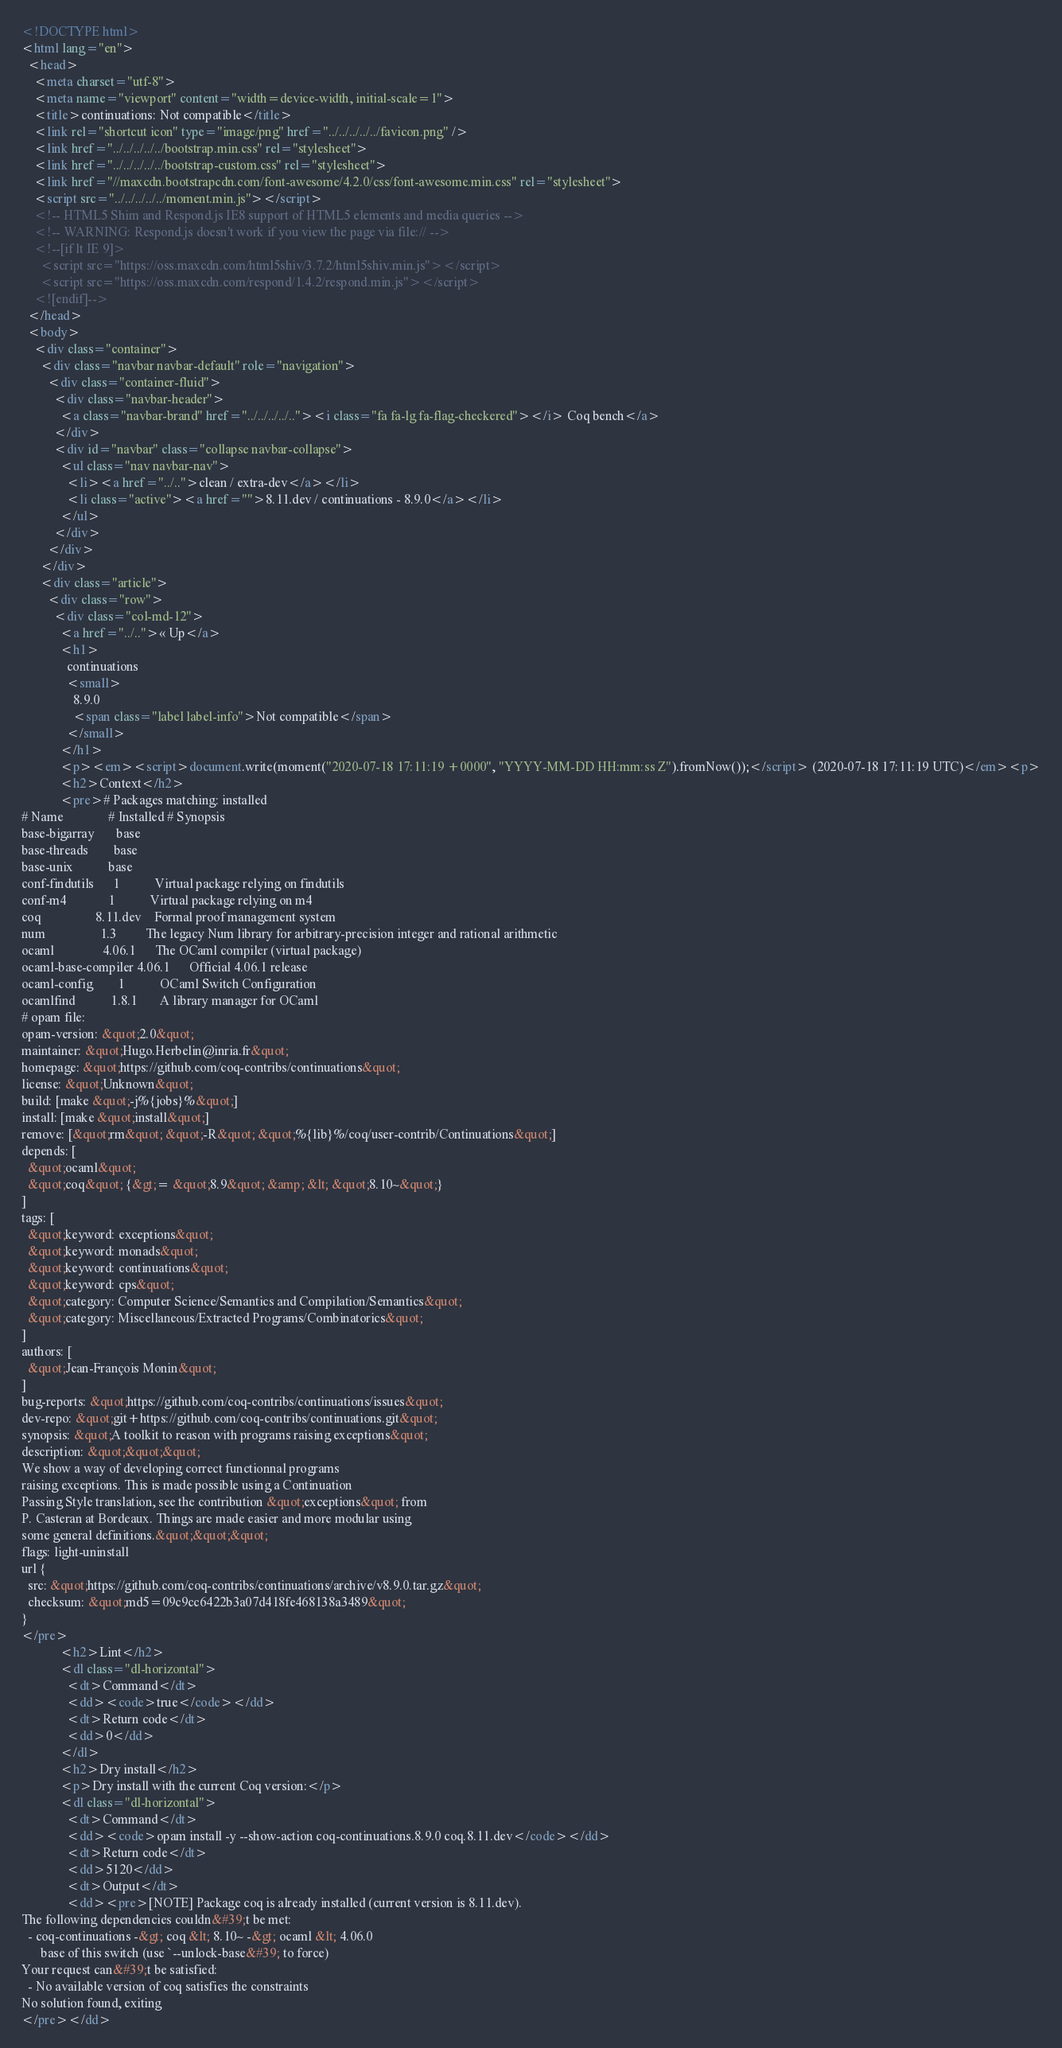Convert code to text. <code><loc_0><loc_0><loc_500><loc_500><_HTML_><!DOCTYPE html>
<html lang="en">
  <head>
    <meta charset="utf-8">
    <meta name="viewport" content="width=device-width, initial-scale=1">
    <title>continuations: Not compatible</title>
    <link rel="shortcut icon" type="image/png" href="../../../../../favicon.png" />
    <link href="../../../../../bootstrap.min.css" rel="stylesheet">
    <link href="../../../../../bootstrap-custom.css" rel="stylesheet">
    <link href="//maxcdn.bootstrapcdn.com/font-awesome/4.2.0/css/font-awesome.min.css" rel="stylesheet">
    <script src="../../../../../moment.min.js"></script>
    <!-- HTML5 Shim and Respond.js IE8 support of HTML5 elements and media queries -->
    <!-- WARNING: Respond.js doesn't work if you view the page via file:// -->
    <!--[if lt IE 9]>
      <script src="https://oss.maxcdn.com/html5shiv/3.7.2/html5shiv.min.js"></script>
      <script src="https://oss.maxcdn.com/respond/1.4.2/respond.min.js"></script>
    <![endif]-->
  </head>
  <body>
    <div class="container">
      <div class="navbar navbar-default" role="navigation">
        <div class="container-fluid">
          <div class="navbar-header">
            <a class="navbar-brand" href="../../../../.."><i class="fa fa-lg fa-flag-checkered"></i> Coq bench</a>
          </div>
          <div id="navbar" class="collapse navbar-collapse">
            <ul class="nav navbar-nav">
              <li><a href="../..">clean / extra-dev</a></li>
              <li class="active"><a href="">8.11.dev / continuations - 8.9.0</a></li>
            </ul>
          </div>
        </div>
      </div>
      <div class="article">
        <div class="row">
          <div class="col-md-12">
            <a href="../..">« Up</a>
            <h1>
              continuations
              <small>
                8.9.0
                <span class="label label-info">Not compatible</span>
              </small>
            </h1>
            <p><em><script>document.write(moment("2020-07-18 17:11:19 +0000", "YYYY-MM-DD HH:mm:ss Z").fromNow());</script> (2020-07-18 17:11:19 UTC)</em><p>
            <h2>Context</h2>
            <pre># Packages matching: installed
# Name              # Installed # Synopsis
base-bigarray       base
base-threads        base
base-unix           base
conf-findutils      1           Virtual package relying on findutils
conf-m4             1           Virtual package relying on m4
coq                 8.11.dev    Formal proof management system
num                 1.3         The legacy Num library for arbitrary-precision integer and rational arithmetic
ocaml               4.06.1      The OCaml compiler (virtual package)
ocaml-base-compiler 4.06.1      Official 4.06.1 release
ocaml-config        1           OCaml Switch Configuration
ocamlfind           1.8.1       A library manager for OCaml
# opam file:
opam-version: &quot;2.0&quot;
maintainer: &quot;Hugo.Herbelin@inria.fr&quot;
homepage: &quot;https://github.com/coq-contribs/continuations&quot;
license: &quot;Unknown&quot;
build: [make &quot;-j%{jobs}%&quot;]
install: [make &quot;install&quot;]
remove: [&quot;rm&quot; &quot;-R&quot; &quot;%{lib}%/coq/user-contrib/Continuations&quot;]
depends: [
  &quot;ocaml&quot;
  &quot;coq&quot; {&gt;= &quot;8.9&quot; &amp; &lt; &quot;8.10~&quot;}
]
tags: [
  &quot;keyword: exceptions&quot;
  &quot;keyword: monads&quot;
  &quot;keyword: continuations&quot;
  &quot;keyword: cps&quot;
  &quot;category: Computer Science/Semantics and Compilation/Semantics&quot;
  &quot;category: Miscellaneous/Extracted Programs/Combinatorics&quot;
]
authors: [
  &quot;Jean-François Monin&quot;
]
bug-reports: &quot;https://github.com/coq-contribs/continuations/issues&quot;
dev-repo: &quot;git+https://github.com/coq-contribs/continuations.git&quot;
synopsis: &quot;A toolkit to reason with programs raising exceptions&quot;
description: &quot;&quot;&quot;
We show a way of developing correct functionnal programs
raising exceptions. This is made possible using a Continuation
Passing Style translation, see the contribution &quot;exceptions&quot; from
P. Casteran at Bordeaux. Things are made easier and more modular using
some general definitions.&quot;&quot;&quot;
flags: light-uninstall
url {
  src: &quot;https://github.com/coq-contribs/continuations/archive/v8.9.0.tar.gz&quot;
  checksum: &quot;md5=09c9cc6422b3a07d418fe468138a3489&quot;
}
</pre>
            <h2>Lint</h2>
            <dl class="dl-horizontal">
              <dt>Command</dt>
              <dd><code>true</code></dd>
              <dt>Return code</dt>
              <dd>0</dd>
            </dl>
            <h2>Dry install</h2>
            <p>Dry install with the current Coq version:</p>
            <dl class="dl-horizontal">
              <dt>Command</dt>
              <dd><code>opam install -y --show-action coq-continuations.8.9.0 coq.8.11.dev</code></dd>
              <dt>Return code</dt>
              <dd>5120</dd>
              <dt>Output</dt>
              <dd><pre>[NOTE] Package coq is already installed (current version is 8.11.dev).
The following dependencies couldn&#39;t be met:
  - coq-continuations -&gt; coq &lt; 8.10~ -&gt; ocaml &lt; 4.06.0
      base of this switch (use `--unlock-base&#39; to force)
Your request can&#39;t be satisfied:
  - No available version of coq satisfies the constraints
No solution found, exiting
</pre></dd></code> 